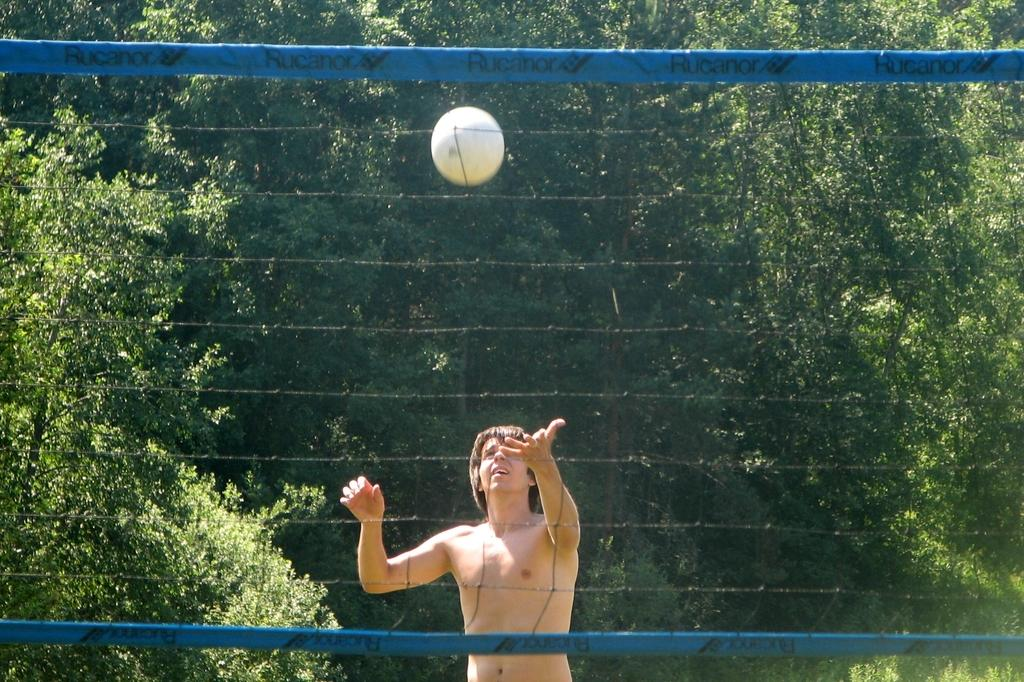What type of sports equipment is in the image? There is a sports netball in the image. Can you describe the person in the image? There is a person standing on the ground in the image. What type of natural environment is visible in the image? There are trees in the image. What type of bath can be seen in the image? There is no bath present in the image. What type of vessel is being used by the person in the image? The person in the image is not using any vessel; they are simply standing on the ground. 